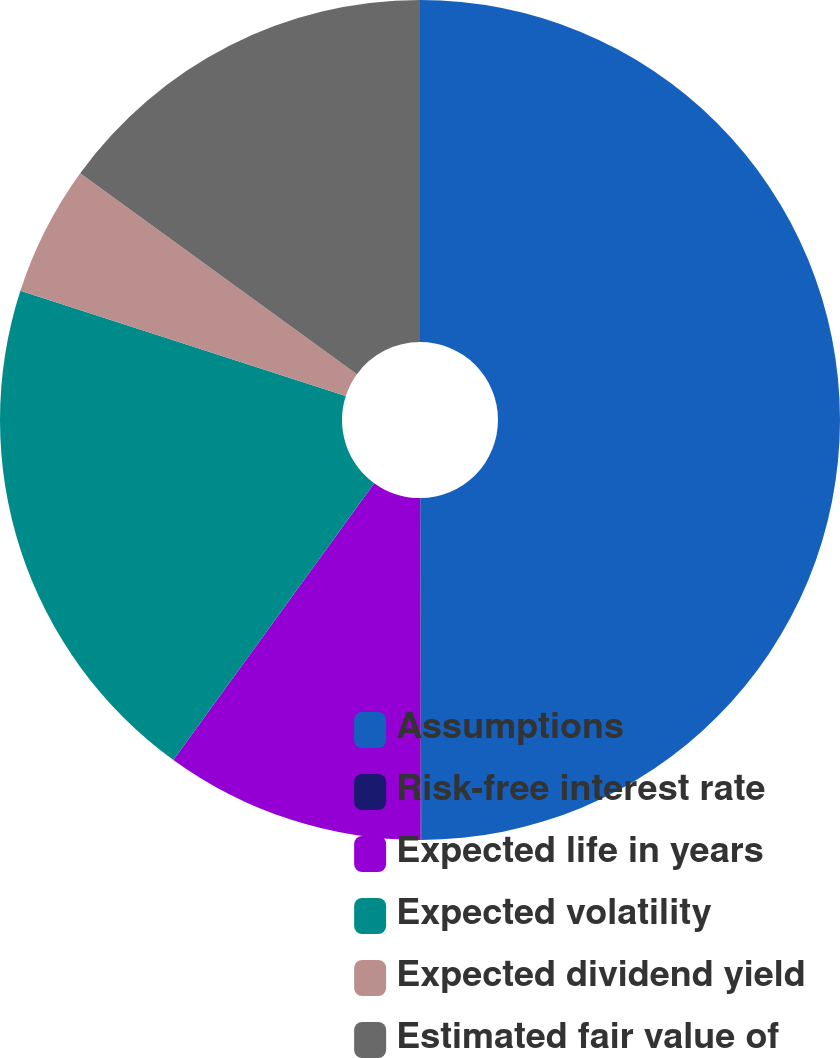Convert chart. <chart><loc_0><loc_0><loc_500><loc_500><pie_chart><fcel>Assumptions<fcel>Risk-free interest rate<fcel>Expected life in years<fcel>Expected volatility<fcel>Expected dividend yield<fcel>Estimated fair value of<nl><fcel>49.95%<fcel>0.03%<fcel>10.01%<fcel>19.99%<fcel>5.02%<fcel>15.0%<nl></chart> 